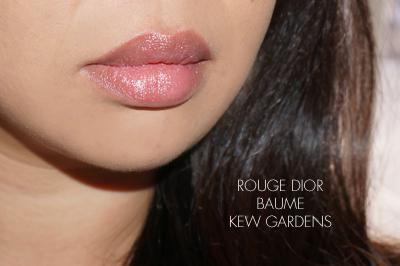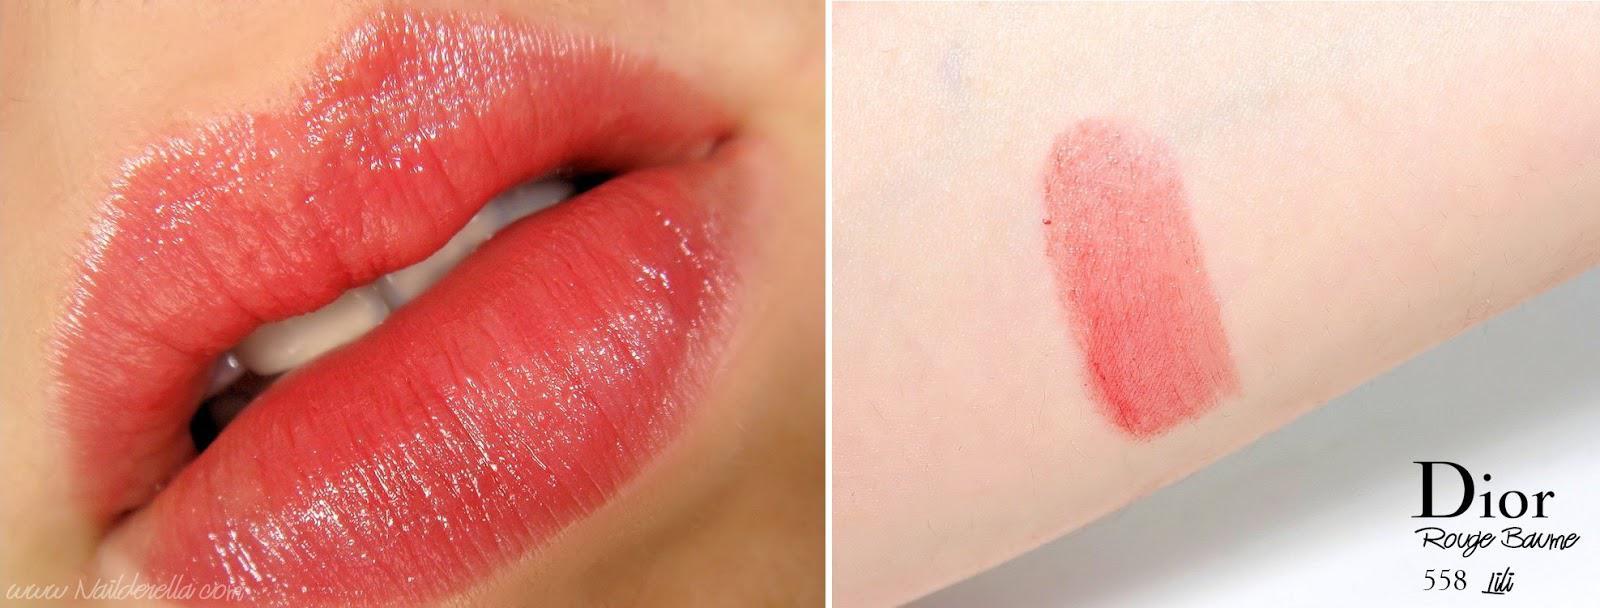The first image is the image on the left, the second image is the image on the right. Given the left and right images, does the statement "Atleast 1 pair of lips can be seen." hold true? Answer yes or no. Yes. The first image is the image on the left, the second image is the image on the right. Considering the images on both sides, is "At least one of the images shows a woman's lips." valid? Answer yes or no. Yes. 